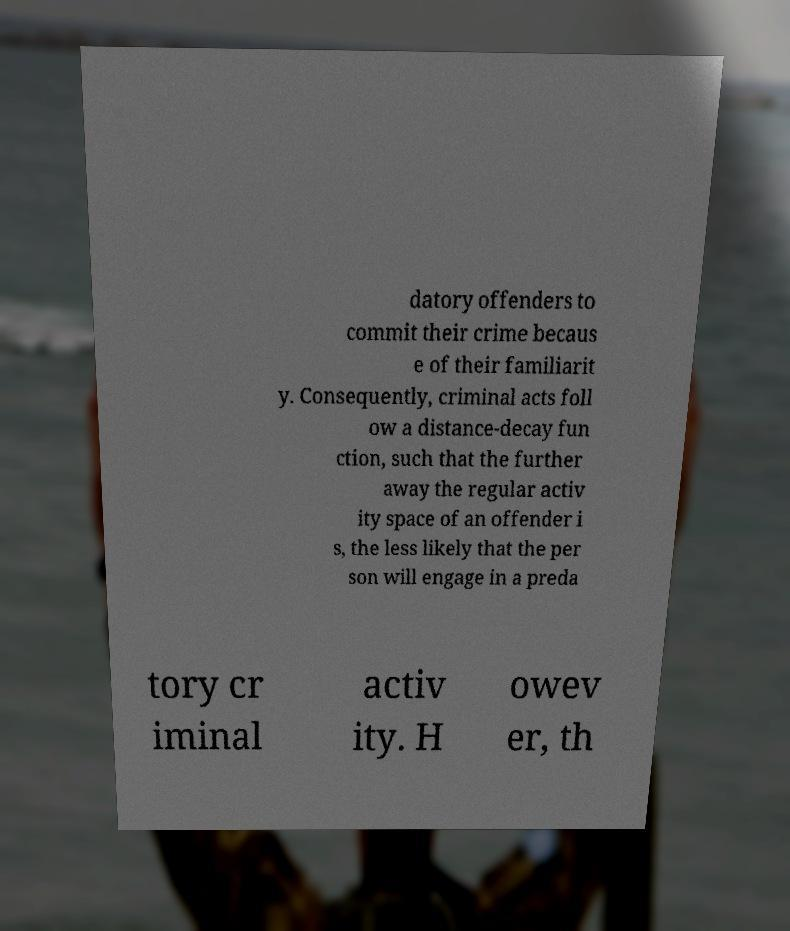Can you accurately transcribe the text from the provided image for me? datory offenders to commit their crime becaus e of their familiarit y. Consequently, criminal acts foll ow a distance-decay fun ction, such that the further away the regular activ ity space of an offender i s, the less likely that the per son will engage in a preda tory cr iminal activ ity. H owev er, th 